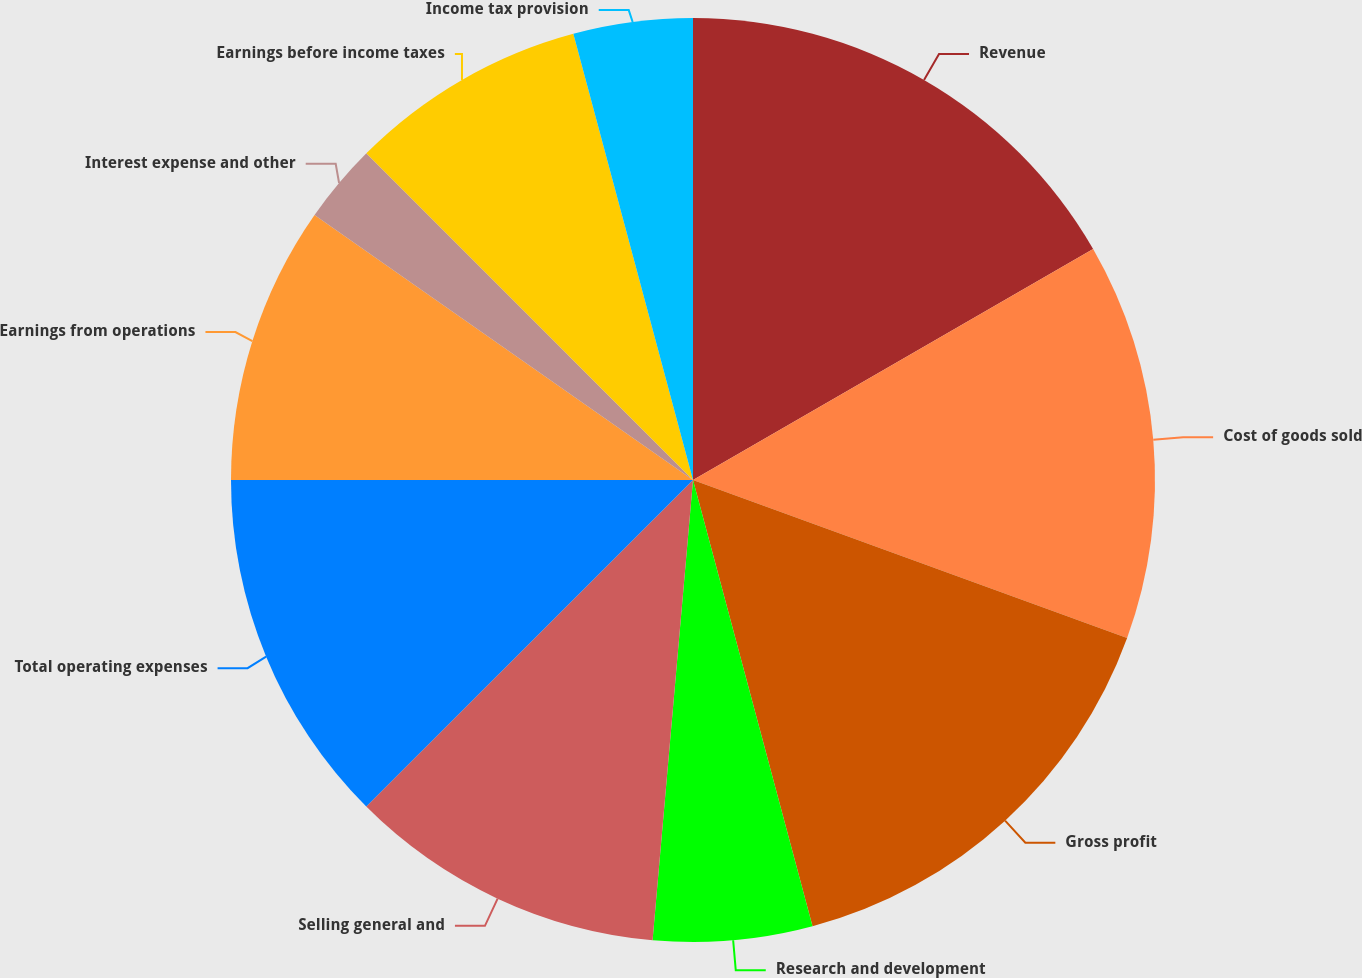Convert chart to OTSL. <chart><loc_0><loc_0><loc_500><loc_500><pie_chart><fcel>Revenue<fcel>Cost of goods sold<fcel>Gross profit<fcel>Research and development<fcel>Selling general and<fcel>Total operating expenses<fcel>Earnings from operations<fcel>Interest expense and other<fcel>Earnings before income taxes<fcel>Income tax provision<nl><fcel>16.67%<fcel>13.89%<fcel>15.28%<fcel>5.56%<fcel>11.11%<fcel>12.5%<fcel>9.72%<fcel>2.78%<fcel>8.33%<fcel>4.17%<nl></chart> 